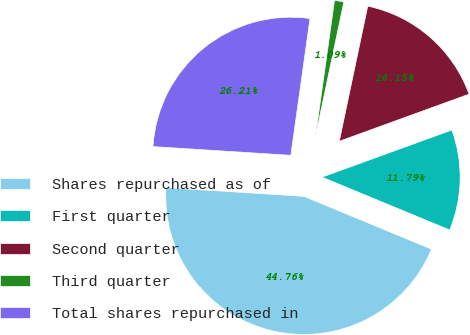<chart> <loc_0><loc_0><loc_500><loc_500><pie_chart><fcel>Shares repurchased as of<fcel>First quarter<fcel>Second quarter<fcel>Third quarter<fcel>Total shares repurchased in<nl><fcel>44.76%<fcel>11.79%<fcel>16.15%<fcel>1.09%<fcel>26.21%<nl></chart> 